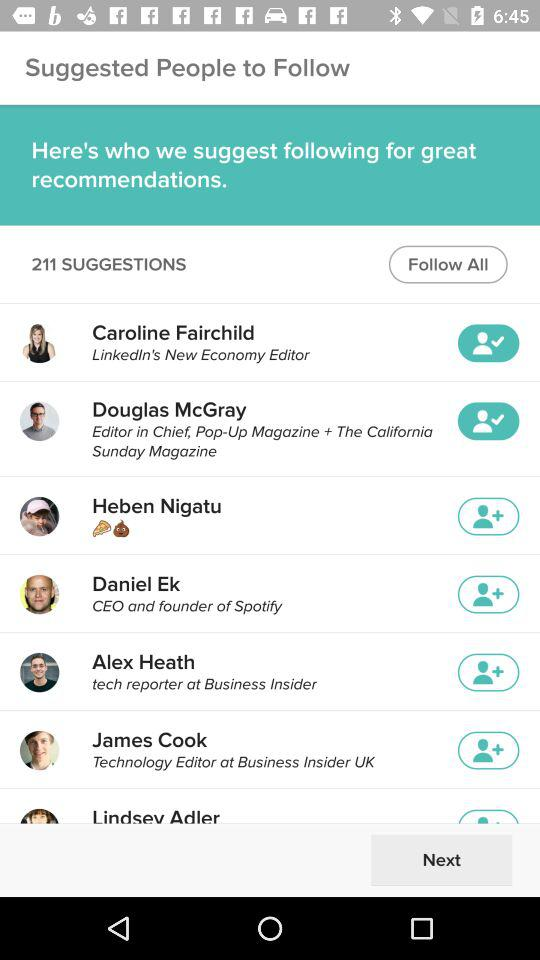What is the title of Caroline Fairchild? Caroline Fairchild's title is "LinkedIn's New Economy Editor". 